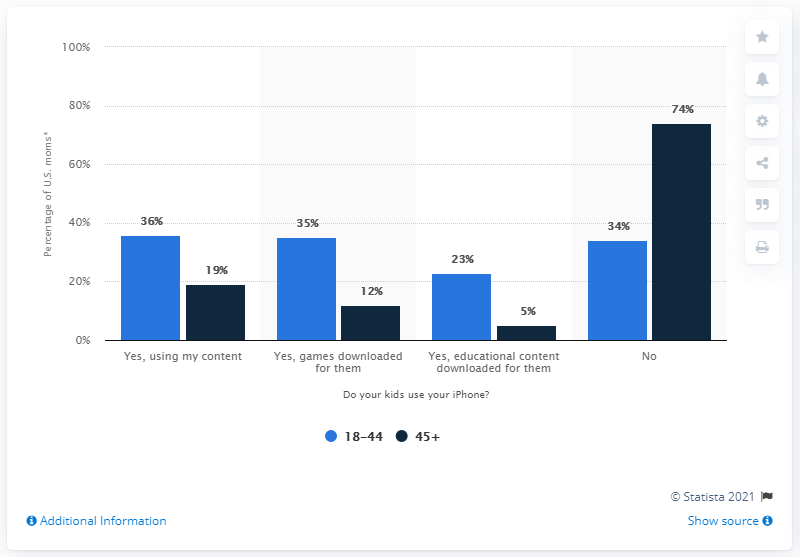Mention a couple of crucial points in this snapshot. According to a survey of parents over the age of 45, a significant percentage allow their children to use iPhones for educational and game downloads. Specifically, 17% of parents in this age group have given their permission for their children to use iPhones for these purposes. According to a survey, 74% of parents over the age of 45 do not allow their children to use iPhones. 